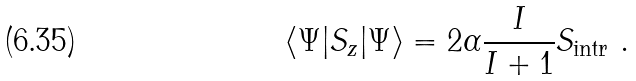<formula> <loc_0><loc_0><loc_500><loc_500>\langle \Psi | S _ { z } | \Psi \rangle = 2 \alpha \frac { I } { I + 1 } S _ { \text {intr} } \ .</formula> 